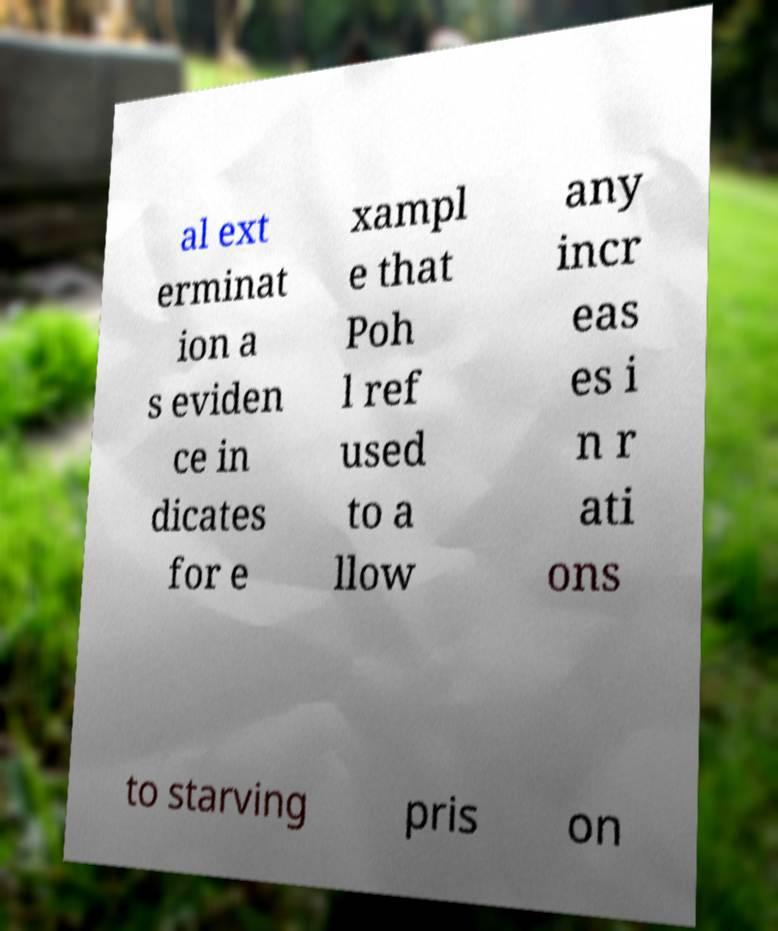Please identify and transcribe the text found in this image. al ext erminat ion a s eviden ce in dicates for e xampl e that Poh l ref used to a llow any incr eas es i n r ati ons to starving pris on 